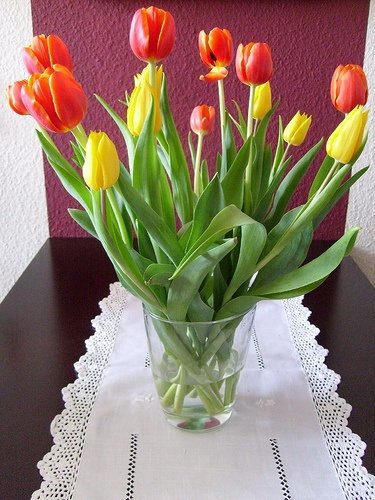Describe the objects in this image and their specific colors. I can see dining table in lightgray, black, and darkgray tones and vase in lightgray, darkgray, darkgreen, and olive tones in this image. 